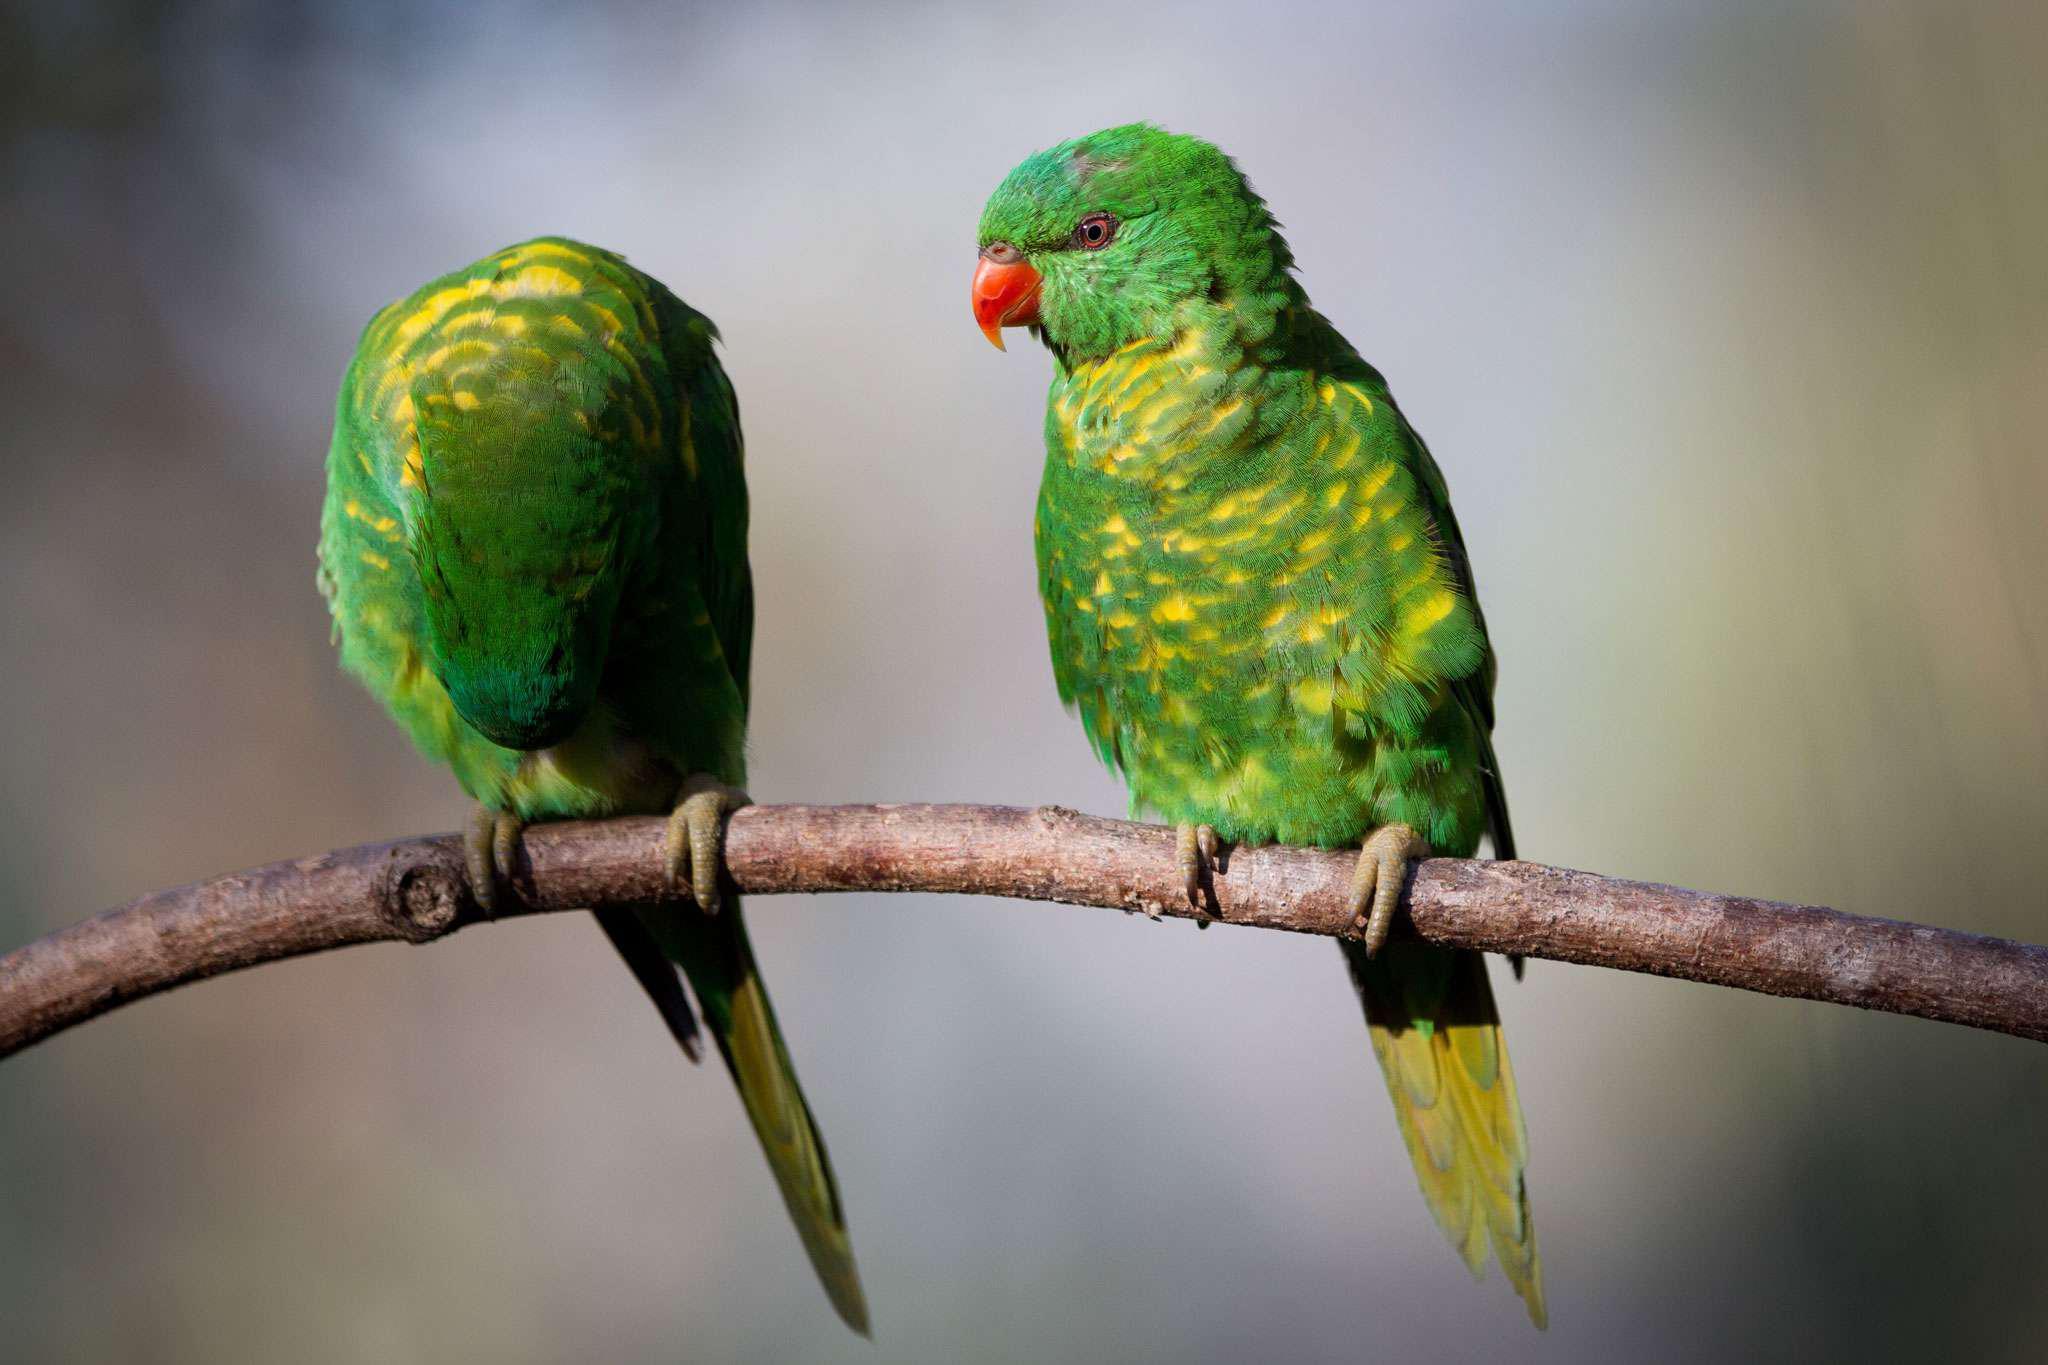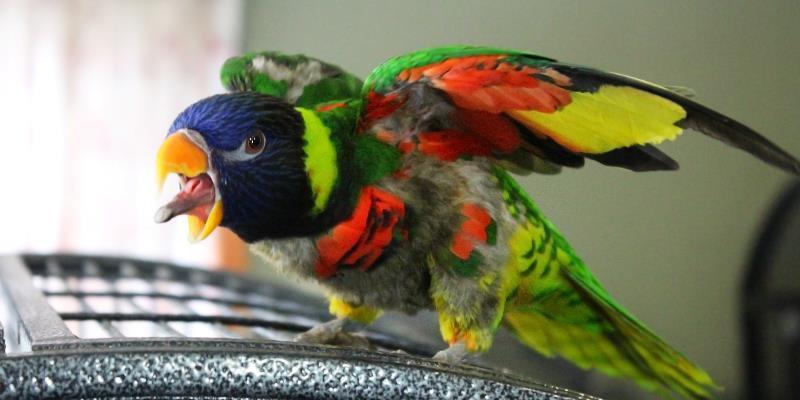The first image is the image on the left, the second image is the image on the right. Assess this claim about the two images: "A person's hand is visible offering a clear plastic cup to one or more colorful birds to feed fro". Correct or not? Answer yes or no. No. The first image is the image on the left, the second image is the image on the right. For the images shown, is this caption "In one image, a hand is holding a plastic cup out for a parrot." true? Answer yes or no. No. 